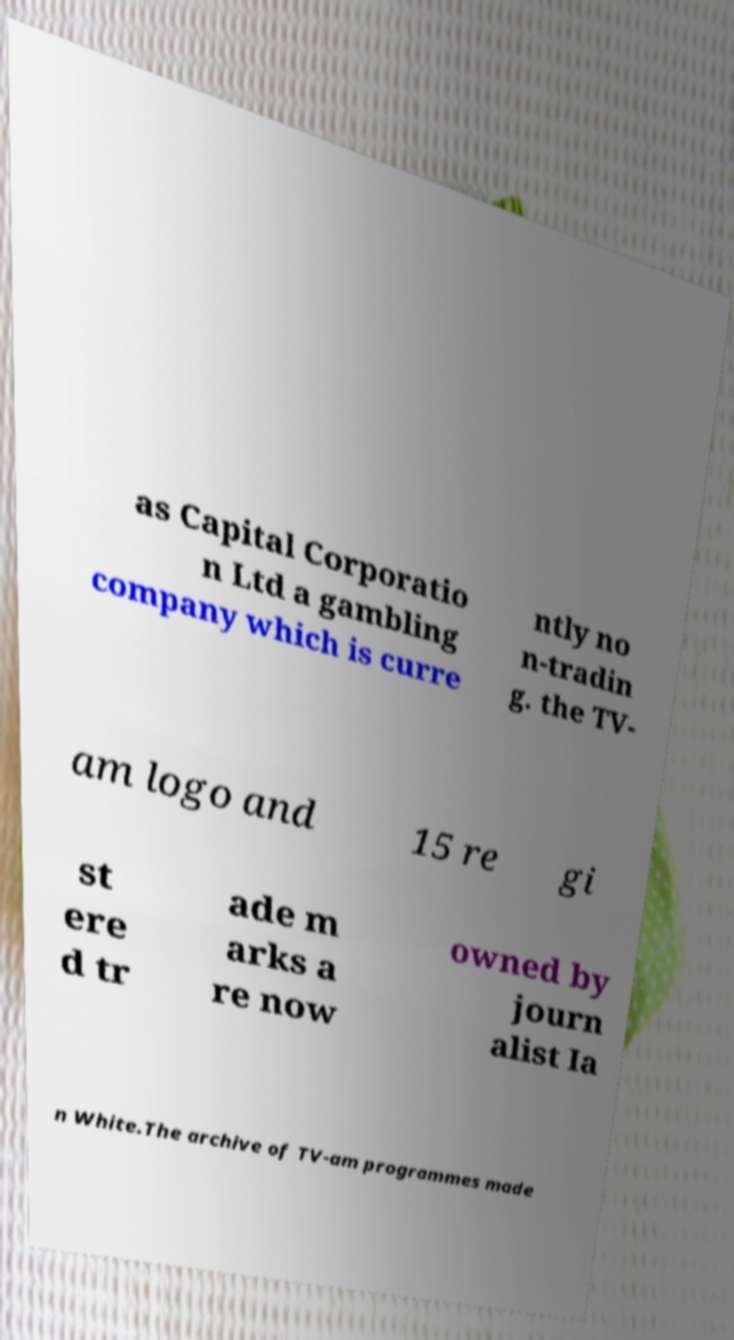Could you assist in decoding the text presented in this image and type it out clearly? as Capital Corporatio n Ltd a gambling company which is curre ntly no n-tradin g. the TV- am logo and 15 re gi st ere d tr ade m arks a re now owned by journ alist Ia n White.The archive of TV-am programmes made 